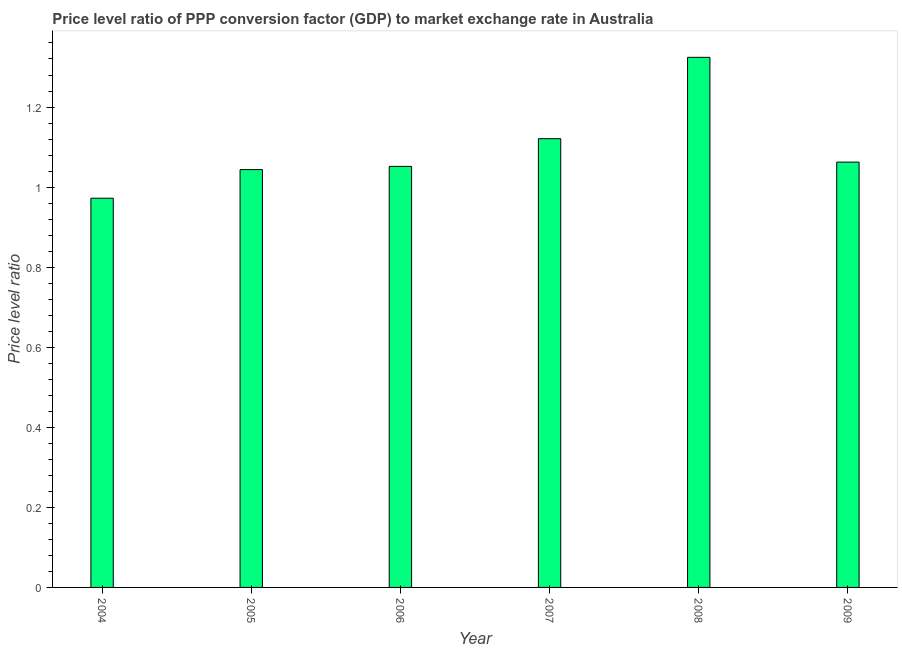Does the graph contain grids?
Give a very brief answer. No. What is the title of the graph?
Provide a short and direct response. Price level ratio of PPP conversion factor (GDP) to market exchange rate in Australia. What is the label or title of the Y-axis?
Offer a very short reply. Price level ratio. What is the price level ratio in 2005?
Provide a short and direct response. 1.04. Across all years, what is the maximum price level ratio?
Offer a very short reply. 1.32. Across all years, what is the minimum price level ratio?
Provide a short and direct response. 0.97. In which year was the price level ratio maximum?
Keep it short and to the point. 2008. In which year was the price level ratio minimum?
Give a very brief answer. 2004. What is the sum of the price level ratio?
Your response must be concise. 6.58. What is the difference between the price level ratio in 2006 and 2008?
Keep it short and to the point. -0.27. What is the average price level ratio per year?
Your response must be concise. 1.1. What is the median price level ratio?
Your answer should be compact. 1.06. Do a majority of the years between 2008 and 2007 (inclusive) have price level ratio greater than 1.08 ?
Offer a very short reply. No. What is the ratio of the price level ratio in 2005 to that in 2006?
Your answer should be compact. 0.99. Is the difference between the price level ratio in 2004 and 2009 greater than the difference between any two years?
Keep it short and to the point. No. What is the difference between the highest and the second highest price level ratio?
Your response must be concise. 0.2. In how many years, is the price level ratio greater than the average price level ratio taken over all years?
Your response must be concise. 2. Are all the bars in the graph horizontal?
Make the answer very short. No. What is the Price level ratio of 2004?
Offer a very short reply. 0.97. What is the Price level ratio in 2005?
Provide a short and direct response. 1.04. What is the Price level ratio in 2006?
Your answer should be very brief. 1.05. What is the Price level ratio in 2007?
Offer a very short reply. 1.12. What is the Price level ratio of 2008?
Make the answer very short. 1.32. What is the Price level ratio in 2009?
Ensure brevity in your answer.  1.06. What is the difference between the Price level ratio in 2004 and 2005?
Your answer should be compact. -0.07. What is the difference between the Price level ratio in 2004 and 2006?
Offer a very short reply. -0.08. What is the difference between the Price level ratio in 2004 and 2007?
Your response must be concise. -0.15. What is the difference between the Price level ratio in 2004 and 2008?
Make the answer very short. -0.35. What is the difference between the Price level ratio in 2004 and 2009?
Provide a short and direct response. -0.09. What is the difference between the Price level ratio in 2005 and 2006?
Your answer should be compact. -0.01. What is the difference between the Price level ratio in 2005 and 2007?
Keep it short and to the point. -0.08. What is the difference between the Price level ratio in 2005 and 2008?
Keep it short and to the point. -0.28. What is the difference between the Price level ratio in 2005 and 2009?
Ensure brevity in your answer.  -0.02. What is the difference between the Price level ratio in 2006 and 2007?
Offer a terse response. -0.07. What is the difference between the Price level ratio in 2006 and 2008?
Offer a very short reply. -0.27. What is the difference between the Price level ratio in 2006 and 2009?
Provide a succinct answer. -0.01. What is the difference between the Price level ratio in 2007 and 2008?
Your answer should be compact. -0.2. What is the difference between the Price level ratio in 2007 and 2009?
Offer a terse response. 0.06. What is the difference between the Price level ratio in 2008 and 2009?
Offer a terse response. 0.26. What is the ratio of the Price level ratio in 2004 to that in 2005?
Offer a terse response. 0.93. What is the ratio of the Price level ratio in 2004 to that in 2006?
Offer a terse response. 0.92. What is the ratio of the Price level ratio in 2004 to that in 2007?
Ensure brevity in your answer.  0.87. What is the ratio of the Price level ratio in 2004 to that in 2008?
Provide a short and direct response. 0.73. What is the ratio of the Price level ratio in 2004 to that in 2009?
Ensure brevity in your answer.  0.92. What is the ratio of the Price level ratio in 2005 to that in 2006?
Your answer should be very brief. 0.99. What is the ratio of the Price level ratio in 2005 to that in 2008?
Provide a succinct answer. 0.79. What is the ratio of the Price level ratio in 2006 to that in 2007?
Ensure brevity in your answer.  0.94. What is the ratio of the Price level ratio in 2006 to that in 2008?
Provide a short and direct response. 0.79. What is the ratio of the Price level ratio in 2006 to that in 2009?
Offer a very short reply. 0.99. What is the ratio of the Price level ratio in 2007 to that in 2008?
Provide a succinct answer. 0.85. What is the ratio of the Price level ratio in 2007 to that in 2009?
Your response must be concise. 1.05. What is the ratio of the Price level ratio in 2008 to that in 2009?
Make the answer very short. 1.25. 